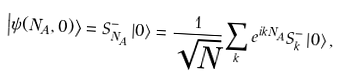<formula> <loc_0><loc_0><loc_500><loc_500>\left | \psi ( N _ { A } , 0 ) \right \rangle = S _ { N _ { A } } ^ { - } \left | 0 \right \rangle = \frac { 1 } { \sqrt { N } } \sum _ { k } e ^ { i k N _ { A } } S _ { k } ^ { - } \left | 0 \right \rangle ,</formula> 